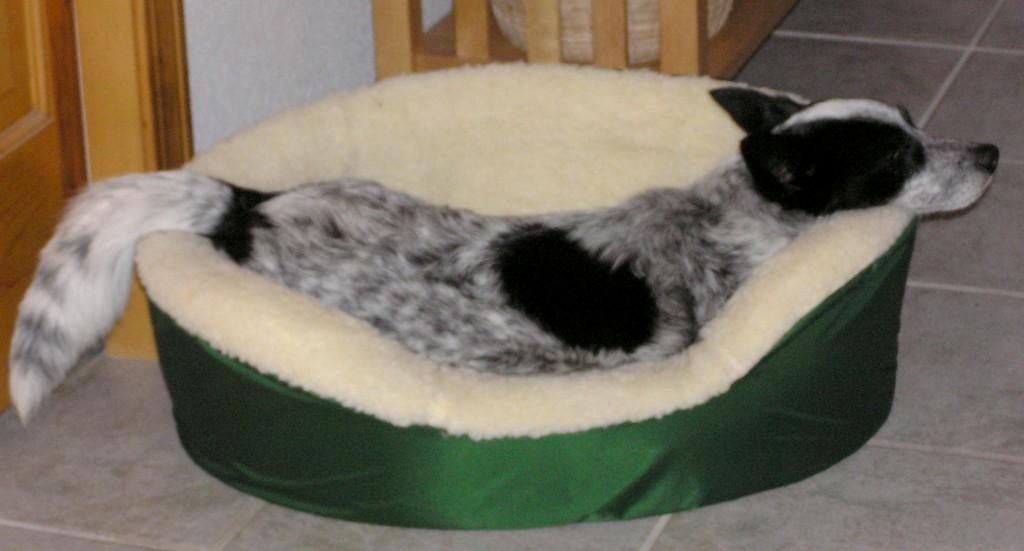Please provide a concise description of this image. In this image I see the couch which is of cream and green in color and on the couch I see a dog which is of black and white in color and I see the floor and I see the wooden thing over here and I see the door and the wall. 